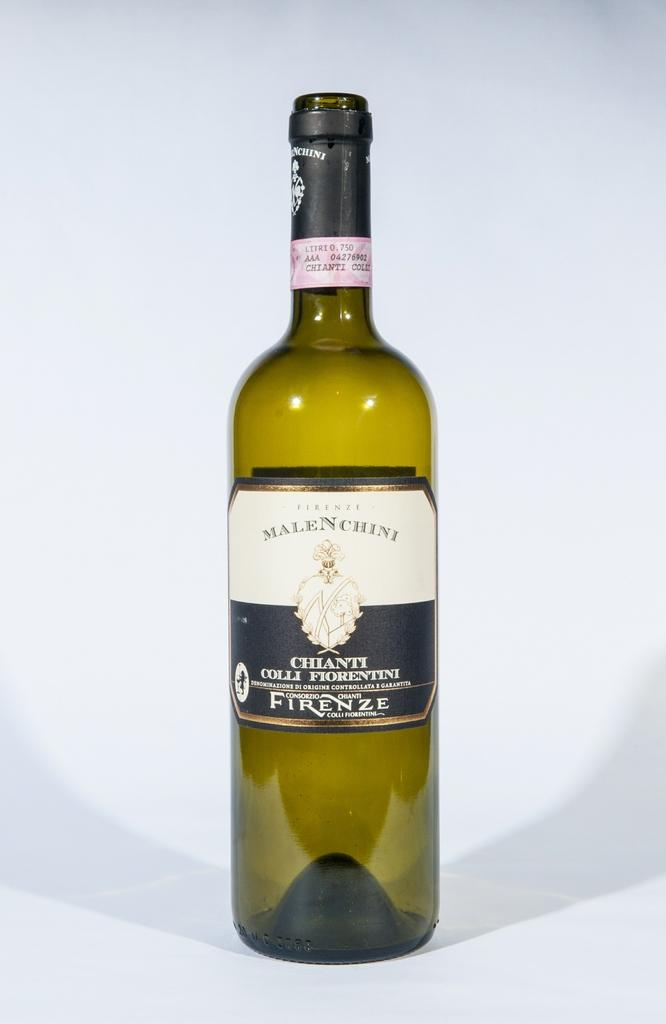Provide a one-sentence caption for the provided image. a wine bottle with the word Firenze on it. 